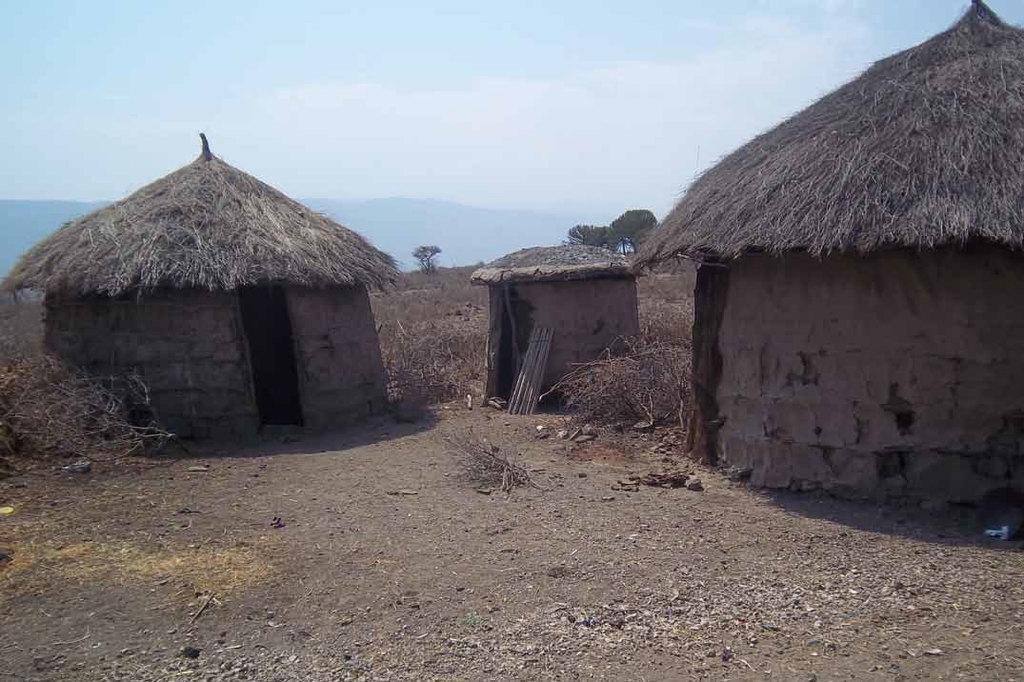In one or two sentences, can you explain what this image depicts? In this image we can see three small huts, some sticks and one object near to the hut. Backside of the but there are some trees, bushes and grass. There are some mountains and at the top there is the sky. 